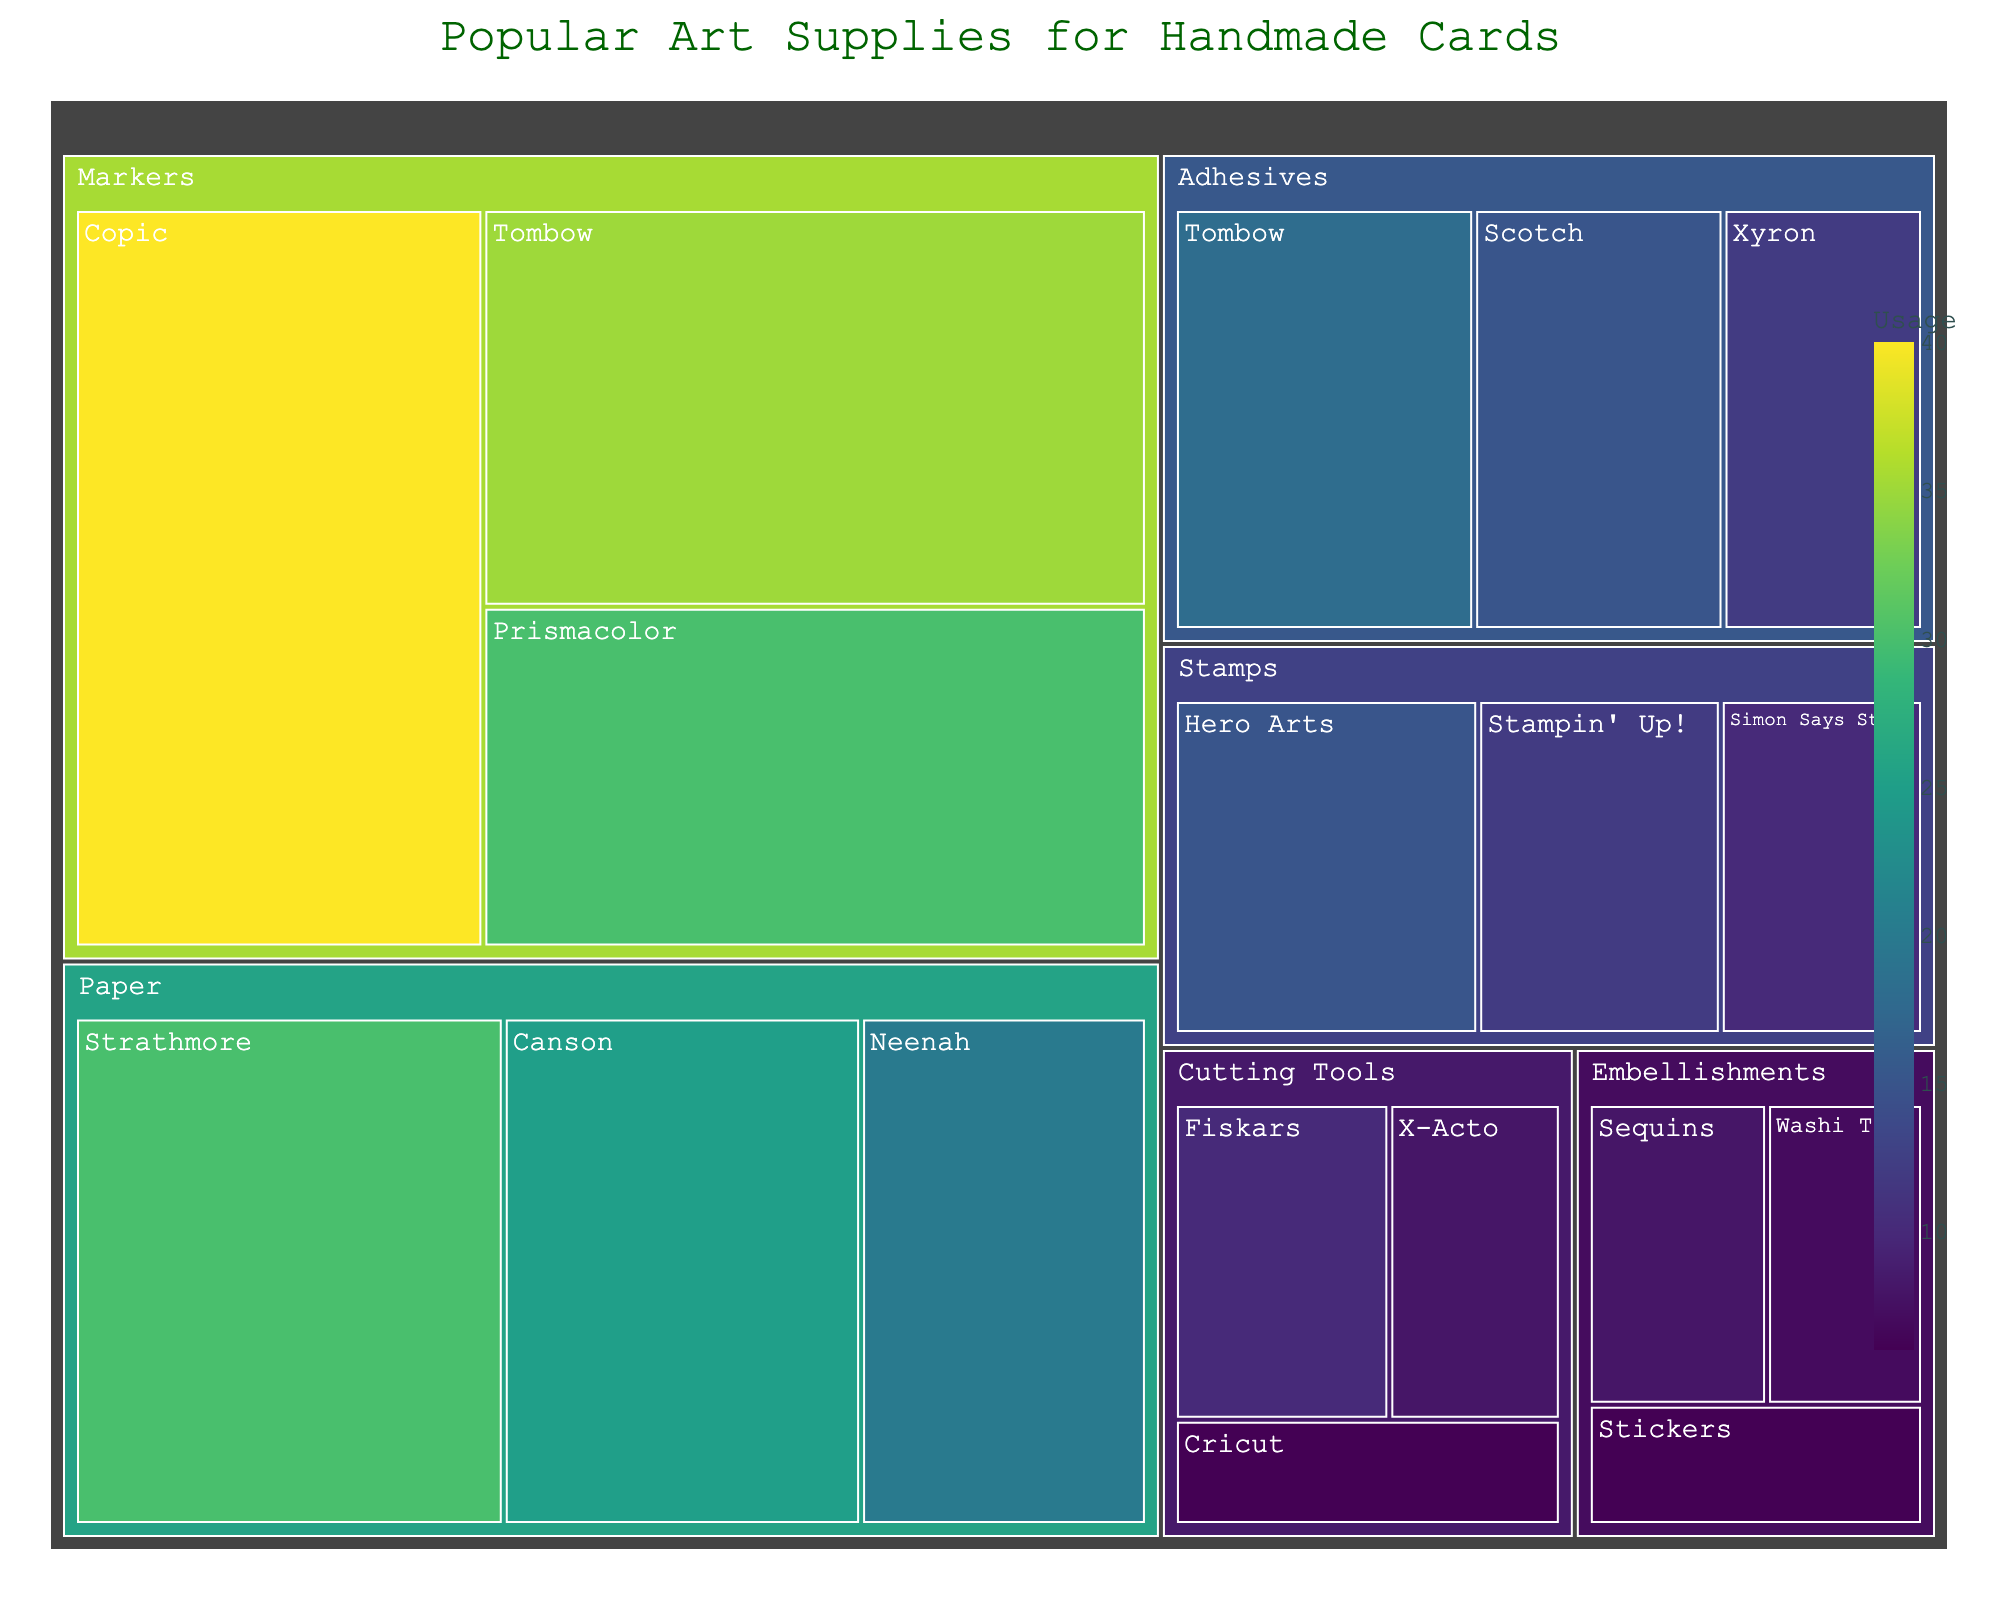what is the most used brand of markers? The treemap's size indicates the usage of each brand. The largest section within markers is Copic, at 40.
Answer: Copic Which brand in the 'Stamps' category has the least usage? Compare the sizes of the sections within the 'Stamps' category. Simon Says Stamp has the smallest section at 10.
Answer: Simon Says Stamp How much more usage does Scotch adhesive have than Xyron adhesive? Find the usage of Scotch which is 15 and Xyron which is 12. The difference is 15 - 12 = 3.
Answer: 3 What is the total usage of all brands in the 'Embellishments' category? Add the individual usages in Embellishments: Sequins (8) + Washi Tape (7) + Stickers (6). The total is 8 + 7 + 6 = 21.
Answer: 21 Is the usage of Copic markers greater than the total usage of all 'Stamps' brands combined? Calculate the total usage of all Stamps: Hero Arts (15) + Stampin' Up! (12) + Simon Says Stamp (10) = 37. Compare this to Copic markers which have a usage of 40. 40 is greater than 37.
Answer: Yes Within the 'Cutting Tools' category, which brand has the middle amount of usage? Compare the sizes within Cutting Tools: Fiskars (10), X-Acto (8), and Cricut (6). The middle value is 8, which corresponds to X-Acto.
Answer: X-Acto How many categories have a brand with over 30 usages? Identify categories with brands over 30: Markers (Copic 40, Tombow 35, Prismacolor 30) and Paper (Strathmore 30) have at least one brand with over 30 usages. There are 2 such categories.
Answer: 2 Compare the total usage of 'Markers' to 'Paper.' Which has higher usage? Calculate the total usage for Markers: Copic (40) + Tombow (35) + Prismacolor (30) = 105. For Paper: Strathmore (30) + Canson (25) + Neenah (20) = 75. Markers (105) is higher than Paper (75).
Answer: Markers What is the least used brand in the 'Cutting Tools' category? Compare the sections within Cutting Tools: Cricut has the smallest value at 6.
Answer: Cricut Which category has the highest number of brands mentioned? Count the brands in each category: Paper (3), Markers (3), Stamps (3), Adhesives (3), Embellishments (3), Cutting Tools (3). They all have an equal number of brands mentioned, which is 3 each.
Answer: All categories have an equal number 